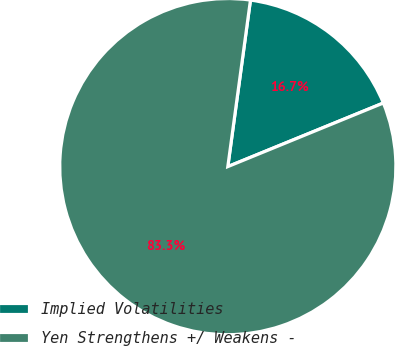<chart> <loc_0><loc_0><loc_500><loc_500><pie_chart><fcel>Implied Volatilities<fcel>Yen Strengthens +/ Weakens -<nl><fcel>16.67%<fcel>83.33%<nl></chart> 